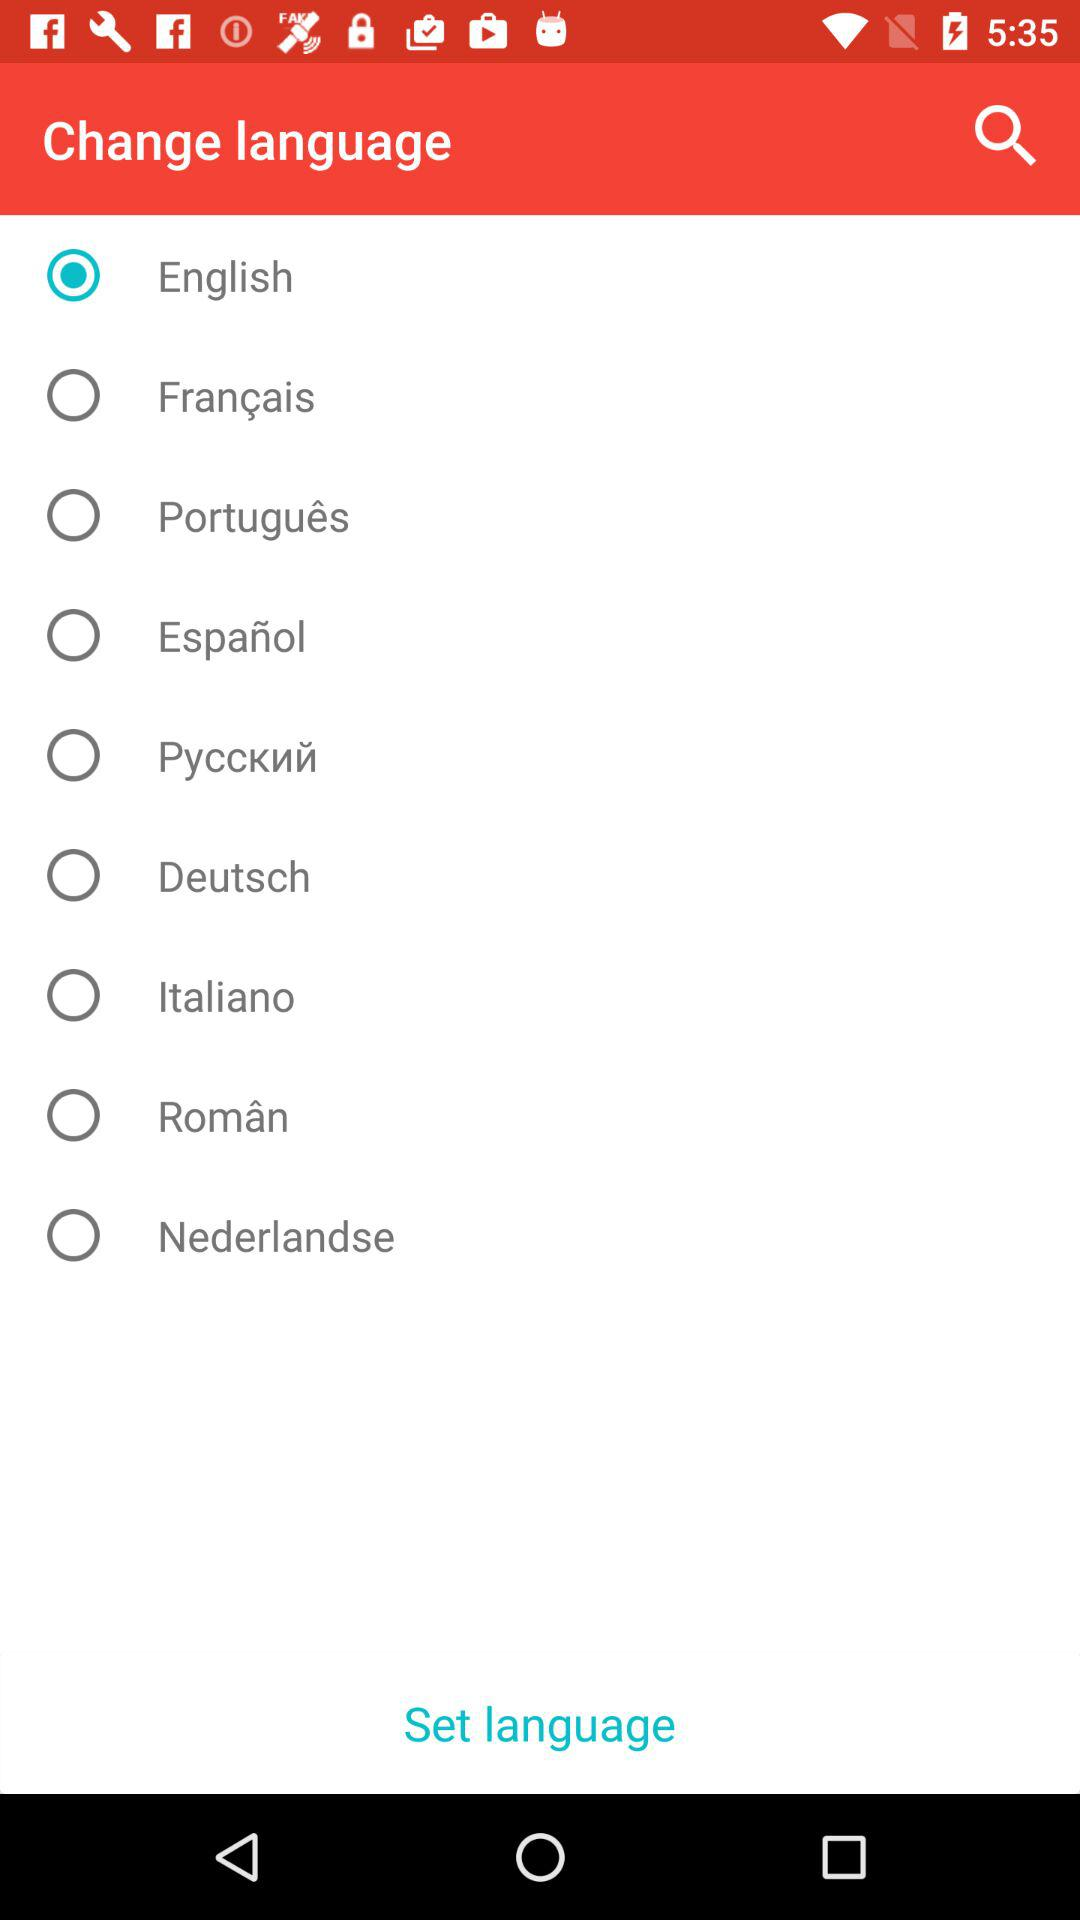How many languages are available in this app?
Answer the question using a single word or phrase. 9 